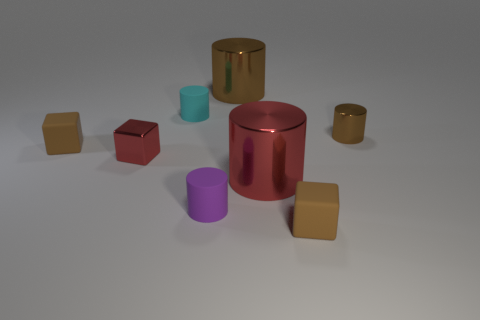Subtract all large red shiny cylinders. How many cylinders are left? 4 Subtract 1 cubes. How many cubes are left? 2 Add 2 tiny rubber things. How many objects exist? 10 Subtract all purple cylinders. How many cylinders are left? 4 Subtract all purple cylinders. Subtract all red spheres. How many cylinders are left? 4 Subtract all cylinders. How many objects are left? 3 Add 7 purple rubber cylinders. How many purple rubber cylinders exist? 8 Subtract 1 red blocks. How many objects are left? 7 Subtract all large blue balls. Subtract all brown things. How many objects are left? 4 Add 2 tiny brown metallic cylinders. How many tiny brown metallic cylinders are left? 3 